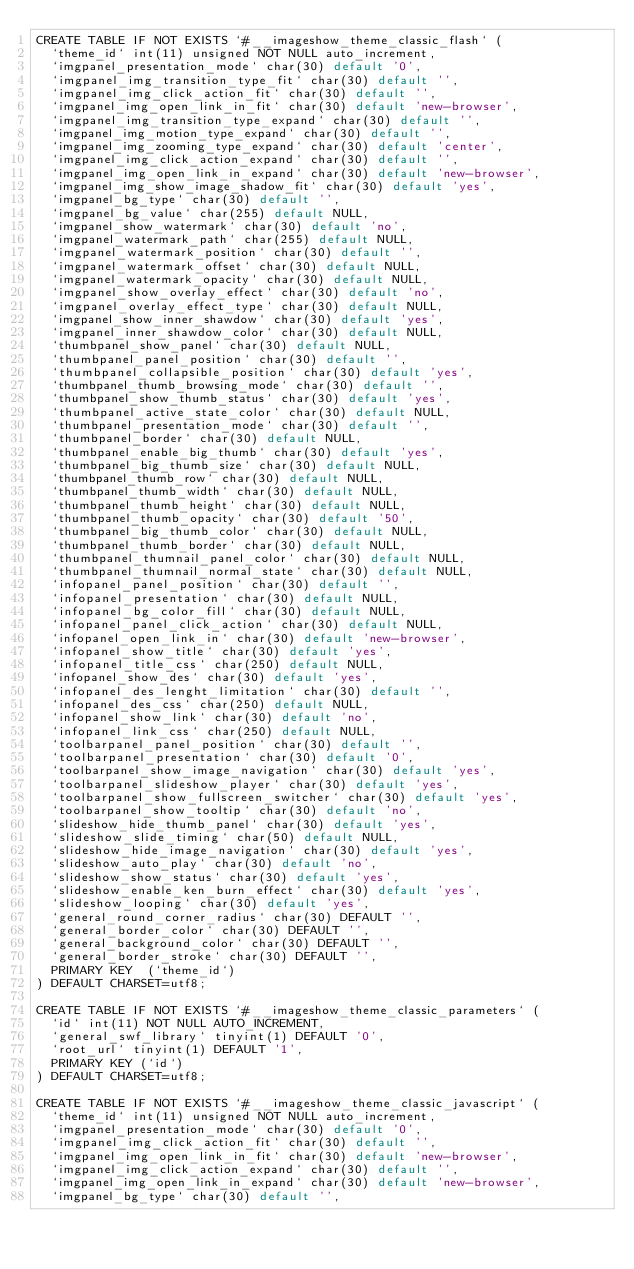Convert code to text. <code><loc_0><loc_0><loc_500><loc_500><_SQL_>CREATE TABLE IF NOT EXISTS `#__imageshow_theme_classic_flash` (
  `theme_id` int(11) unsigned NOT NULL auto_increment,
  `imgpanel_presentation_mode` char(30) default '0',
  `imgpanel_img_transition_type_fit` char(30) default '',
  `imgpanel_img_click_action_fit` char(30) default '',
  `imgpanel_img_open_link_in_fit` char(30) default 'new-browser',
  `imgpanel_img_transition_type_expand` char(30) default '',
  `imgpanel_img_motion_type_expand` char(30) default '',
  `imgpanel_img_zooming_type_expand` char(30) default 'center',
  `imgpanel_img_click_action_expand` char(30) default '',
  `imgpanel_img_open_link_in_expand` char(30) default 'new-browser',
  `imgpanel_img_show_image_shadow_fit` char(30) default 'yes',
  `imgpanel_bg_type` char(30) default '',
  `imgpanel_bg_value` char(255) default NULL,
  `imgpanel_show_watermark` char(30) default 'no',
  `imgpanel_watermark_path` char(255) default NULL,
  `imgpanel_watermark_position` char(30) default '',
  `imgpanel_watermark_offset` char(30) default NULL,
  `imgpanel_watermark_opacity` char(30) default NULL,
  `imgpanel_show_overlay_effect` char(30) default 'no',
  `imgpanel_overlay_effect_type` char(30) default NULL,
  `imgpanel_show_inner_shawdow` char(30) default 'yes',
  `imgpanel_inner_shawdow_color` char(30) default NULL,
  `thumbpanel_show_panel` char(30) default NULL,
  `thumbpanel_panel_position` char(30) default '',
  `thumbpanel_collapsible_position` char(30) default 'yes',
  `thumbpanel_thumb_browsing_mode` char(30) default '',
  `thumbpanel_show_thumb_status` char(30) default 'yes',
  `thumbpanel_active_state_color` char(30) default NULL,
  `thumbpanel_presentation_mode` char(30) default '',
  `thumbpanel_border` char(30) default NULL,
  `thumbpanel_enable_big_thumb` char(30) default 'yes',
  `thumbpanel_big_thumb_size` char(30) default NULL,
  `thumbpanel_thumb_row` char(30) default NULL,
  `thumbpanel_thumb_width` char(30) default NULL,
  `thumbpanel_thumb_height` char(30) default NULL,
  `thumbpanel_thumb_opacity` char(30) default '50',
  `thumbpanel_big_thumb_color` char(30) default NULL,
  `thumbpanel_thumb_border` char(30) default NULL,
  `thumbpanel_thumnail_panel_color` char(30) default NULL,
  `thumbpanel_thumnail_normal_state` char(30) default NULL,
  `infopanel_panel_position` char(30) default '',
  `infopanel_presentation` char(30) default NULL,
  `infopanel_bg_color_fill` char(30) default NULL,
  `infopanel_panel_click_action` char(30) default NULL,
  `infopanel_open_link_in` char(30) default 'new-browser',
  `infopanel_show_title` char(30) default 'yes',
  `infopanel_title_css` char(250) default NULL,
  `infopanel_show_des` char(30) default 'yes',
  `infopanel_des_lenght_limitation` char(30) default '',
  `infopanel_des_css` char(250) default NULL,
  `infopanel_show_link` char(30) default 'no',
  `infopanel_link_css` char(250) default NULL,
  `toolbarpanel_panel_position` char(30) default '',
  `toolbarpanel_presentation` char(30) default '0',
  `toolbarpanel_show_image_navigation` char(30) default 'yes',
  `toolbarpanel_slideshow_player` char(30) default 'yes',
  `toolbarpanel_show_fullscreen_switcher` char(30) default 'yes',
  `toolbarpanel_show_tooltip` char(30) default 'no',
  `slideshow_hide_thumb_panel` char(30) default 'yes',
  `slideshow_slide_timing` char(50) default NULL,
  `slideshow_hide_image_navigation` char(30) default 'yes',
  `slideshow_auto_play` char(30) default 'no',
  `slideshow_show_status` char(30) default 'yes',
  `slideshow_enable_ken_burn_effect` char(30) default 'yes',
  `slideshow_looping` char(30) default 'yes',
  `general_round_corner_radius` char(30) DEFAULT '',
  `general_border_color` char(30) DEFAULT '',
  `general_background_color` char(30) DEFAULT '',
  `general_border_stroke` char(30) DEFAULT '',
  PRIMARY KEY  (`theme_id`)
) DEFAULT CHARSET=utf8;

CREATE TABLE IF NOT EXISTS `#__imageshow_theme_classic_parameters` (
  `id` int(11) NOT NULL AUTO_INCREMENT,
  `general_swf_library` tinyint(1) DEFAULT '0',
  `root_url` tinyint(1) DEFAULT '1',
  PRIMARY KEY (`id`)
) DEFAULT CHARSET=utf8;

CREATE TABLE IF NOT EXISTS `#__imageshow_theme_classic_javascript` (
  `theme_id` int(11) unsigned NOT NULL auto_increment,
  `imgpanel_presentation_mode` char(30) default '0',
  `imgpanel_img_click_action_fit` char(30) default '',
  `imgpanel_img_open_link_in_fit` char(30) default 'new-browser',
  `imgpanel_img_click_action_expand` char(30) default '',
  `imgpanel_img_open_link_in_expand` char(30) default 'new-browser',
  `imgpanel_bg_type` char(30) default '',</code> 